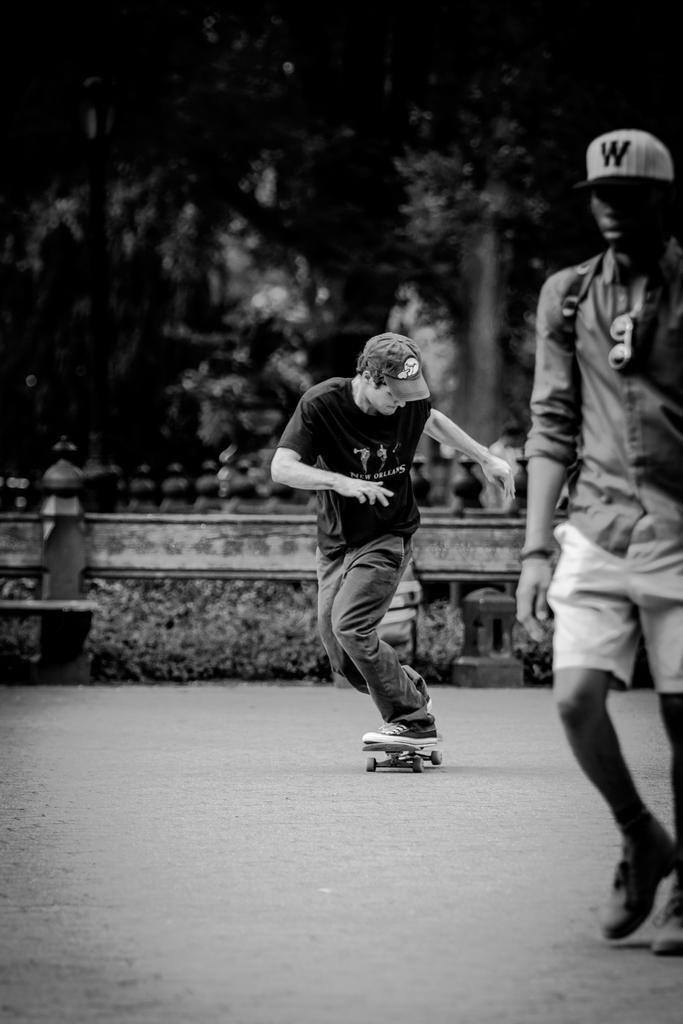What is the person on the right side of the image doing? The person on the right side of the image is walking. What is the person in the middle of the image doing? The person in the middle of the image is skating. What objects can be seen in the image besides the people? There are plates, a wall, and trees visible in the image. How would you describe the lighting in the image? The image is slightly dark. What type of structure is the person on the left side of the image building with the string? There is no person on the left side of the image, and no structure or string is present. 